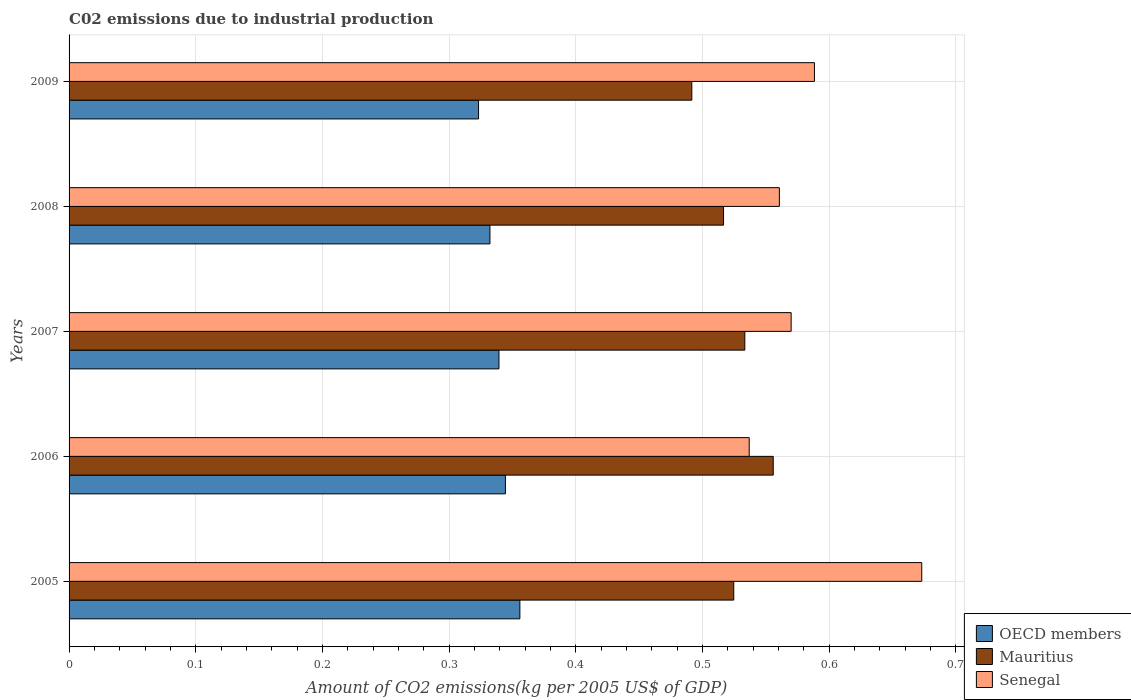How many different coloured bars are there?
Ensure brevity in your answer.  3. How many bars are there on the 5th tick from the top?
Keep it short and to the point. 3. What is the label of the 4th group of bars from the top?
Your answer should be very brief. 2006. What is the amount of CO2 emitted due to industrial production in Mauritius in 2008?
Your answer should be very brief. 0.52. Across all years, what is the maximum amount of CO2 emitted due to industrial production in Senegal?
Provide a short and direct response. 0.67. Across all years, what is the minimum amount of CO2 emitted due to industrial production in Mauritius?
Offer a very short reply. 0.49. In which year was the amount of CO2 emitted due to industrial production in Senegal minimum?
Offer a terse response. 2006. What is the total amount of CO2 emitted due to industrial production in Mauritius in the graph?
Your response must be concise. 2.62. What is the difference between the amount of CO2 emitted due to industrial production in Senegal in 2006 and that in 2007?
Your answer should be compact. -0.03. What is the difference between the amount of CO2 emitted due to industrial production in OECD members in 2006 and the amount of CO2 emitted due to industrial production in Senegal in 2007?
Give a very brief answer. -0.23. What is the average amount of CO2 emitted due to industrial production in Senegal per year?
Provide a succinct answer. 0.59. In the year 2005, what is the difference between the amount of CO2 emitted due to industrial production in OECD members and amount of CO2 emitted due to industrial production in Mauritius?
Provide a succinct answer. -0.17. What is the ratio of the amount of CO2 emitted due to industrial production in Mauritius in 2005 to that in 2009?
Offer a very short reply. 1.07. What is the difference between the highest and the second highest amount of CO2 emitted due to industrial production in Mauritius?
Provide a short and direct response. 0.02. What is the difference between the highest and the lowest amount of CO2 emitted due to industrial production in Mauritius?
Give a very brief answer. 0.06. What does the 3rd bar from the top in 2007 represents?
Make the answer very short. OECD members. What does the 2nd bar from the bottom in 2008 represents?
Your response must be concise. Mauritius. Is it the case that in every year, the sum of the amount of CO2 emitted due to industrial production in Mauritius and amount of CO2 emitted due to industrial production in Senegal is greater than the amount of CO2 emitted due to industrial production in OECD members?
Give a very brief answer. Yes. How many bars are there?
Provide a succinct answer. 15. Are all the bars in the graph horizontal?
Provide a succinct answer. Yes. What is the difference between two consecutive major ticks on the X-axis?
Your answer should be very brief. 0.1. Does the graph contain grids?
Keep it short and to the point. Yes. How many legend labels are there?
Make the answer very short. 3. How are the legend labels stacked?
Ensure brevity in your answer.  Vertical. What is the title of the graph?
Provide a short and direct response. C02 emissions due to industrial production. Does "Costa Rica" appear as one of the legend labels in the graph?
Make the answer very short. No. What is the label or title of the X-axis?
Your answer should be compact. Amount of CO2 emissions(kg per 2005 US$ of GDP). What is the label or title of the Y-axis?
Keep it short and to the point. Years. What is the Amount of CO2 emissions(kg per 2005 US$ of GDP) of OECD members in 2005?
Give a very brief answer. 0.36. What is the Amount of CO2 emissions(kg per 2005 US$ of GDP) in Mauritius in 2005?
Make the answer very short. 0.52. What is the Amount of CO2 emissions(kg per 2005 US$ of GDP) in Senegal in 2005?
Your answer should be very brief. 0.67. What is the Amount of CO2 emissions(kg per 2005 US$ of GDP) in OECD members in 2006?
Make the answer very short. 0.34. What is the Amount of CO2 emissions(kg per 2005 US$ of GDP) of Mauritius in 2006?
Provide a succinct answer. 0.56. What is the Amount of CO2 emissions(kg per 2005 US$ of GDP) in Senegal in 2006?
Your answer should be very brief. 0.54. What is the Amount of CO2 emissions(kg per 2005 US$ of GDP) in OECD members in 2007?
Keep it short and to the point. 0.34. What is the Amount of CO2 emissions(kg per 2005 US$ of GDP) of Mauritius in 2007?
Your response must be concise. 0.53. What is the Amount of CO2 emissions(kg per 2005 US$ of GDP) of Senegal in 2007?
Your answer should be compact. 0.57. What is the Amount of CO2 emissions(kg per 2005 US$ of GDP) in OECD members in 2008?
Ensure brevity in your answer.  0.33. What is the Amount of CO2 emissions(kg per 2005 US$ of GDP) in Mauritius in 2008?
Keep it short and to the point. 0.52. What is the Amount of CO2 emissions(kg per 2005 US$ of GDP) in Senegal in 2008?
Your answer should be compact. 0.56. What is the Amount of CO2 emissions(kg per 2005 US$ of GDP) in OECD members in 2009?
Ensure brevity in your answer.  0.32. What is the Amount of CO2 emissions(kg per 2005 US$ of GDP) of Mauritius in 2009?
Offer a terse response. 0.49. What is the Amount of CO2 emissions(kg per 2005 US$ of GDP) in Senegal in 2009?
Offer a very short reply. 0.59. Across all years, what is the maximum Amount of CO2 emissions(kg per 2005 US$ of GDP) in OECD members?
Ensure brevity in your answer.  0.36. Across all years, what is the maximum Amount of CO2 emissions(kg per 2005 US$ of GDP) of Mauritius?
Make the answer very short. 0.56. Across all years, what is the maximum Amount of CO2 emissions(kg per 2005 US$ of GDP) of Senegal?
Provide a succinct answer. 0.67. Across all years, what is the minimum Amount of CO2 emissions(kg per 2005 US$ of GDP) of OECD members?
Your answer should be very brief. 0.32. Across all years, what is the minimum Amount of CO2 emissions(kg per 2005 US$ of GDP) in Mauritius?
Ensure brevity in your answer.  0.49. Across all years, what is the minimum Amount of CO2 emissions(kg per 2005 US$ of GDP) of Senegal?
Your answer should be very brief. 0.54. What is the total Amount of CO2 emissions(kg per 2005 US$ of GDP) in OECD members in the graph?
Offer a very short reply. 1.69. What is the total Amount of CO2 emissions(kg per 2005 US$ of GDP) of Mauritius in the graph?
Keep it short and to the point. 2.62. What is the total Amount of CO2 emissions(kg per 2005 US$ of GDP) of Senegal in the graph?
Provide a succinct answer. 2.93. What is the difference between the Amount of CO2 emissions(kg per 2005 US$ of GDP) of OECD members in 2005 and that in 2006?
Your response must be concise. 0.01. What is the difference between the Amount of CO2 emissions(kg per 2005 US$ of GDP) of Mauritius in 2005 and that in 2006?
Your response must be concise. -0.03. What is the difference between the Amount of CO2 emissions(kg per 2005 US$ of GDP) in Senegal in 2005 and that in 2006?
Give a very brief answer. 0.14. What is the difference between the Amount of CO2 emissions(kg per 2005 US$ of GDP) of OECD members in 2005 and that in 2007?
Give a very brief answer. 0.02. What is the difference between the Amount of CO2 emissions(kg per 2005 US$ of GDP) of Mauritius in 2005 and that in 2007?
Give a very brief answer. -0.01. What is the difference between the Amount of CO2 emissions(kg per 2005 US$ of GDP) of Senegal in 2005 and that in 2007?
Your response must be concise. 0.1. What is the difference between the Amount of CO2 emissions(kg per 2005 US$ of GDP) of OECD members in 2005 and that in 2008?
Your answer should be compact. 0.02. What is the difference between the Amount of CO2 emissions(kg per 2005 US$ of GDP) of Mauritius in 2005 and that in 2008?
Offer a very short reply. 0.01. What is the difference between the Amount of CO2 emissions(kg per 2005 US$ of GDP) of Senegal in 2005 and that in 2008?
Offer a very short reply. 0.11. What is the difference between the Amount of CO2 emissions(kg per 2005 US$ of GDP) of OECD members in 2005 and that in 2009?
Your answer should be very brief. 0.03. What is the difference between the Amount of CO2 emissions(kg per 2005 US$ of GDP) of Mauritius in 2005 and that in 2009?
Provide a short and direct response. 0.03. What is the difference between the Amount of CO2 emissions(kg per 2005 US$ of GDP) in Senegal in 2005 and that in 2009?
Ensure brevity in your answer.  0.08. What is the difference between the Amount of CO2 emissions(kg per 2005 US$ of GDP) in OECD members in 2006 and that in 2007?
Offer a very short reply. 0.01. What is the difference between the Amount of CO2 emissions(kg per 2005 US$ of GDP) in Mauritius in 2006 and that in 2007?
Ensure brevity in your answer.  0.02. What is the difference between the Amount of CO2 emissions(kg per 2005 US$ of GDP) in Senegal in 2006 and that in 2007?
Make the answer very short. -0.03. What is the difference between the Amount of CO2 emissions(kg per 2005 US$ of GDP) in OECD members in 2006 and that in 2008?
Give a very brief answer. 0.01. What is the difference between the Amount of CO2 emissions(kg per 2005 US$ of GDP) in Mauritius in 2006 and that in 2008?
Make the answer very short. 0.04. What is the difference between the Amount of CO2 emissions(kg per 2005 US$ of GDP) in Senegal in 2006 and that in 2008?
Offer a terse response. -0.02. What is the difference between the Amount of CO2 emissions(kg per 2005 US$ of GDP) in OECD members in 2006 and that in 2009?
Offer a very short reply. 0.02. What is the difference between the Amount of CO2 emissions(kg per 2005 US$ of GDP) in Mauritius in 2006 and that in 2009?
Your response must be concise. 0.06. What is the difference between the Amount of CO2 emissions(kg per 2005 US$ of GDP) in Senegal in 2006 and that in 2009?
Your response must be concise. -0.05. What is the difference between the Amount of CO2 emissions(kg per 2005 US$ of GDP) in OECD members in 2007 and that in 2008?
Offer a very short reply. 0.01. What is the difference between the Amount of CO2 emissions(kg per 2005 US$ of GDP) of Mauritius in 2007 and that in 2008?
Your answer should be compact. 0.02. What is the difference between the Amount of CO2 emissions(kg per 2005 US$ of GDP) of Senegal in 2007 and that in 2008?
Make the answer very short. 0.01. What is the difference between the Amount of CO2 emissions(kg per 2005 US$ of GDP) of OECD members in 2007 and that in 2009?
Provide a succinct answer. 0.02. What is the difference between the Amount of CO2 emissions(kg per 2005 US$ of GDP) of Mauritius in 2007 and that in 2009?
Offer a terse response. 0.04. What is the difference between the Amount of CO2 emissions(kg per 2005 US$ of GDP) in Senegal in 2007 and that in 2009?
Your answer should be compact. -0.02. What is the difference between the Amount of CO2 emissions(kg per 2005 US$ of GDP) in OECD members in 2008 and that in 2009?
Keep it short and to the point. 0.01. What is the difference between the Amount of CO2 emissions(kg per 2005 US$ of GDP) of Mauritius in 2008 and that in 2009?
Offer a terse response. 0.03. What is the difference between the Amount of CO2 emissions(kg per 2005 US$ of GDP) of Senegal in 2008 and that in 2009?
Your answer should be compact. -0.03. What is the difference between the Amount of CO2 emissions(kg per 2005 US$ of GDP) in OECD members in 2005 and the Amount of CO2 emissions(kg per 2005 US$ of GDP) in Senegal in 2006?
Provide a short and direct response. -0.18. What is the difference between the Amount of CO2 emissions(kg per 2005 US$ of GDP) of Mauritius in 2005 and the Amount of CO2 emissions(kg per 2005 US$ of GDP) of Senegal in 2006?
Offer a very short reply. -0.01. What is the difference between the Amount of CO2 emissions(kg per 2005 US$ of GDP) of OECD members in 2005 and the Amount of CO2 emissions(kg per 2005 US$ of GDP) of Mauritius in 2007?
Your answer should be very brief. -0.18. What is the difference between the Amount of CO2 emissions(kg per 2005 US$ of GDP) in OECD members in 2005 and the Amount of CO2 emissions(kg per 2005 US$ of GDP) in Senegal in 2007?
Your response must be concise. -0.21. What is the difference between the Amount of CO2 emissions(kg per 2005 US$ of GDP) of Mauritius in 2005 and the Amount of CO2 emissions(kg per 2005 US$ of GDP) of Senegal in 2007?
Ensure brevity in your answer.  -0.05. What is the difference between the Amount of CO2 emissions(kg per 2005 US$ of GDP) of OECD members in 2005 and the Amount of CO2 emissions(kg per 2005 US$ of GDP) of Mauritius in 2008?
Offer a terse response. -0.16. What is the difference between the Amount of CO2 emissions(kg per 2005 US$ of GDP) of OECD members in 2005 and the Amount of CO2 emissions(kg per 2005 US$ of GDP) of Senegal in 2008?
Provide a succinct answer. -0.2. What is the difference between the Amount of CO2 emissions(kg per 2005 US$ of GDP) of Mauritius in 2005 and the Amount of CO2 emissions(kg per 2005 US$ of GDP) of Senegal in 2008?
Your answer should be compact. -0.04. What is the difference between the Amount of CO2 emissions(kg per 2005 US$ of GDP) in OECD members in 2005 and the Amount of CO2 emissions(kg per 2005 US$ of GDP) in Mauritius in 2009?
Your response must be concise. -0.14. What is the difference between the Amount of CO2 emissions(kg per 2005 US$ of GDP) of OECD members in 2005 and the Amount of CO2 emissions(kg per 2005 US$ of GDP) of Senegal in 2009?
Keep it short and to the point. -0.23. What is the difference between the Amount of CO2 emissions(kg per 2005 US$ of GDP) of Mauritius in 2005 and the Amount of CO2 emissions(kg per 2005 US$ of GDP) of Senegal in 2009?
Your answer should be very brief. -0.06. What is the difference between the Amount of CO2 emissions(kg per 2005 US$ of GDP) of OECD members in 2006 and the Amount of CO2 emissions(kg per 2005 US$ of GDP) of Mauritius in 2007?
Offer a very short reply. -0.19. What is the difference between the Amount of CO2 emissions(kg per 2005 US$ of GDP) in OECD members in 2006 and the Amount of CO2 emissions(kg per 2005 US$ of GDP) in Senegal in 2007?
Give a very brief answer. -0.23. What is the difference between the Amount of CO2 emissions(kg per 2005 US$ of GDP) in Mauritius in 2006 and the Amount of CO2 emissions(kg per 2005 US$ of GDP) in Senegal in 2007?
Keep it short and to the point. -0.01. What is the difference between the Amount of CO2 emissions(kg per 2005 US$ of GDP) in OECD members in 2006 and the Amount of CO2 emissions(kg per 2005 US$ of GDP) in Mauritius in 2008?
Make the answer very short. -0.17. What is the difference between the Amount of CO2 emissions(kg per 2005 US$ of GDP) of OECD members in 2006 and the Amount of CO2 emissions(kg per 2005 US$ of GDP) of Senegal in 2008?
Give a very brief answer. -0.22. What is the difference between the Amount of CO2 emissions(kg per 2005 US$ of GDP) of Mauritius in 2006 and the Amount of CO2 emissions(kg per 2005 US$ of GDP) of Senegal in 2008?
Provide a succinct answer. -0. What is the difference between the Amount of CO2 emissions(kg per 2005 US$ of GDP) in OECD members in 2006 and the Amount of CO2 emissions(kg per 2005 US$ of GDP) in Mauritius in 2009?
Your answer should be compact. -0.15. What is the difference between the Amount of CO2 emissions(kg per 2005 US$ of GDP) in OECD members in 2006 and the Amount of CO2 emissions(kg per 2005 US$ of GDP) in Senegal in 2009?
Keep it short and to the point. -0.24. What is the difference between the Amount of CO2 emissions(kg per 2005 US$ of GDP) of Mauritius in 2006 and the Amount of CO2 emissions(kg per 2005 US$ of GDP) of Senegal in 2009?
Your response must be concise. -0.03. What is the difference between the Amount of CO2 emissions(kg per 2005 US$ of GDP) in OECD members in 2007 and the Amount of CO2 emissions(kg per 2005 US$ of GDP) in Mauritius in 2008?
Give a very brief answer. -0.18. What is the difference between the Amount of CO2 emissions(kg per 2005 US$ of GDP) of OECD members in 2007 and the Amount of CO2 emissions(kg per 2005 US$ of GDP) of Senegal in 2008?
Provide a short and direct response. -0.22. What is the difference between the Amount of CO2 emissions(kg per 2005 US$ of GDP) in Mauritius in 2007 and the Amount of CO2 emissions(kg per 2005 US$ of GDP) in Senegal in 2008?
Provide a short and direct response. -0.03. What is the difference between the Amount of CO2 emissions(kg per 2005 US$ of GDP) in OECD members in 2007 and the Amount of CO2 emissions(kg per 2005 US$ of GDP) in Mauritius in 2009?
Your answer should be compact. -0.15. What is the difference between the Amount of CO2 emissions(kg per 2005 US$ of GDP) of OECD members in 2007 and the Amount of CO2 emissions(kg per 2005 US$ of GDP) of Senegal in 2009?
Offer a very short reply. -0.25. What is the difference between the Amount of CO2 emissions(kg per 2005 US$ of GDP) in Mauritius in 2007 and the Amount of CO2 emissions(kg per 2005 US$ of GDP) in Senegal in 2009?
Offer a terse response. -0.06. What is the difference between the Amount of CO2 emissions(kg per 2005 US$ of GDP) in OECD members in 2008 and the Amount of CO2 emissions(kg per 2005 US$ of GDP) in Mauritius in 2009?
Keep it short and to the point. -0.16. What is the difference between the Amount of CO2 emissions(kg per 2005 US$ of GDP) of OECD members in 2008 and the Amount of CO2 emissions(kg per 2005 US$ of GDP) of Senegal in 2009?
Offer a terse response. -0.26. What is the difference between the Amount of CO2 emissions(kg per 2005 US$ of GDP) of Mauritius in 2008 and the Amount of CO2 emissions(kg per 2005 US$ of GDP) of Senegal in 2009?
Your answer should be very brief. -0.07. What is the average Amount of CO2 emissions(kg per 2005 US$ of GDP) in OECD members per year?
Your answer should be compact. 0.34. What is the average Amount of CO2 emissions(kg per 2005 US$ of GDP) in Mauritius per year?
Provide a succinct answer. 0.52. What is the average Amount of CO2 emissions(kg per 2005 US$ of GDP) of Senegal per year?
Make the answer very short. 0.59. In the year 2005, what is the difference between the Amount of CO2 emissions(kg per 2005 US$ of GDP) in OECD members and Amount of CO2 emissions(kg per 2005 US$ of GDP) in Mauritius?
Your answer should be very brief. -0.17. In the year 2005, what is the difference between the Amount of CO2 emissions(kg per 2005 US$ of GDP) of OECD members and Amount of CO2 emissions(kg per 2005 US$ of GDP) of Senegal?
Provide a succinct answer. -0.32. In the year 2005, what is the difference between the Amount of CO2 emissions(kg per 2005 US$ of GDP) in Mauritius and Amount of CO2 emissions(kg per 2005 US$ of GDP) in Senegal?
Give a very brief answer. -0.15. In the year 2006, what is the difference between the Amount of CO2 emissions(kg per 2005 US$ of GDP) of OECD members and Amount of CO2 emissions(kg per 2005 US$ of GDP) of Mauritius?
Your answer should be very brief. -0.21. In the year 2006, what is the difference between the Amount of CO2 emissions(kg per 2005 US$ of GDP) of OECD members and Amount of CO2 emissions(kg per 2005 US$ of GDP) of Senegal?
Provide a short and direct response. -0.19. In the year 2006, what is the difference between the Amount of CO2 emissions(kg per 2005 US$ of GDP) in Mauritius and Amount of CO2 emissions(kg per 2005 US$ of GDP) in Senegal?
Provide a short and direct response. 0.02. In the year 2007, what is the difference between the Amount of CO2 emissions(kg per 2005 US$ of GDP) in OECD members and Amount of CO2 emissions(kg per 2005 US$ of GDP) in Mauritius?
Provide a short and direct response. -0.19. In the year 2007, what is the difference between the Amount of CO2 emissions(kg per 2005 US$ of GDP) of OECD members and Amount of CO2 emissions(kg per 2005 US$ of GDP) of Senegal?
Make the answer very short. -0.23. In the year 2007, what is the difference between the Amount of CO2 emissions(kg per 2005 US$ of GDP) of Mauritius and Amount of CO2 emissions(kg per 2005 US$ of GDP) of Senegal?
Provide a succinct answer. -0.04. In the year 2008, what is the difference between the Amount of CO2 emissions(kg per 2005 US$ of GDP) in OECD members and Amount of CO2 emissions(kg per 2005 US$ of GDP) in Mauritius?
Give a very brief answer. -0.18. In the year 2008, what is the difference between the Amount of CO2 emissions(kg per 2005 US$ of GDP) of OECD members and Amount of CO2 emissions(kg per 2005 US$ of GDP) of Senegal?
Give a very brief answer. -0.23. In the year 2008, what is the difference between the Amount of CO2 emissions(kg per 2005 US$ of GDP) of Mauritius and Amount of CO2 emissions(kg per 2005 US$ of GDP) of Senegal?
Keep it short and to the point. -0.04. In the year 2009, what is the difference between the Amount of CO2 emissions(kg per 2005 US$ of GDP) of OECD members and Amount of CO2 emissions(kg per 2005 US$ of GDP) of Mauritius?
Give a very brief answer. -0.17. In the year 2009, what is the difference between the Amount of CO2 emissions(kg per 2005 US$ of GDP) in OECD members and Amount of CO2 emissions(kg per 2005 US$ of GDP) in Senegal?
Make the answer very short. -0.27. In the year 2009, what is the difference between the Amount of CO2 emissions(kg per 2005 US$ of GDP) of Mauritius and Amount of CO2 emissions(kg per 2005 US$ of GDP) of Senegal?
Offer a very short reply. -0.1. What is the ratio of the Amount of CO2 emissions(kg per 2005 US$ of GDP) of OECD members in 2005 to that in 2006?
Offer a terse response. 1.03. What is the ratio of the Amount of CO2 emissions(kg per 2005 US$ of GDP) of Mauritius in 2005 to that in 2006?
Your response must be concise. 0.94. What is the ratio of the Amount of CO2 emissions(kg per 2005 US$ of GDP) in Senegal in 2005 to that in 2006?
Your answer should be very brief. 1.25. What is the ratio of the Amount of CO2 emissions(kg per 2005 US$ of GDP) in OECD members in 2005 to that in 2007?
Your answer should be very brief. 1.05. What is the ratio of the Amount of CO2 emissions(kg per 2005 US$ of GDP) of Mauritius in 2005 to that in 2007?
Make the answer very short. 0.98. What is the ratio of the Amount of CO2 emissions(kg per 2005 US$ of GDP) in Senegal in 2005 to that in 2007?
Keep it short and to the point. 1.18. What is the ratio of the Amount of CO2 emissions(kg per 2005 US$ of GDP) of OECD members in 2005 to that in 2008?
Your response must be concise. 1.07. What is the ratio of the Amount of CO2 emissions(kg per 2005 US$ of GDP) of Mauritius in 2005 to that in 2008?
Your answer should be compact. 1.02. What is the ratio of the Amount of CO2 emissions(kg per 2005 US$ of GDP) of Senegal in 2005 to that in 2008?
Ensure brevity in your answer.  1.2. What is the ratio of the Amount of CO2 emissions(kg per 2005 US$ of GDP) in OECD members in 2005 to that in 2009?
Make the answer very short. 1.1. What is the ratio of the Amount of CO2 emissions(kg per 2005 US$ of GDP) in Mauritius in 2005 to that in 2009?
Provide a short and direct response. 1.07. What is the ratio of the Amount of CO2 emissions(kg per 2005 US$ of GDP) in Senegal in 2005 to that in 2009?
Ensure brevity in your answer.  1.14. What is the ratio of the Amount of CO2 emissions(kg per 2005 US$ of GDP) in Mauritius in 2006 to that in 2007?
Offer a terse response. 1.04. What is the ratio of the Amount of CO2 emissions(kg per 2005 US$ of GDP) of Senegal in 2006 to that in 2007?
Make the answer very short. 0.94. What is the ratio of the Amount of CO2 emissions(kg per 2005 US$ of GDP) in OECD members in 2006 to that in 2008?
Your response must be concise. 1.04. What is the ratio of the Amount of CO2 emissions(kg per 2005 US$ of GDP) of Mauritius in 2006 to that in 2008?
Provide a succinct answer. 1.08. What is the ratio of the Amount of CO2 emissions(kg per 2005 US$ of GDP) of Senegal in 2006 to that in 2008?
Your response must be concise. 0.96. What is the ratio of the Amount of CO2 emissions(kg per 2005 US$ of GDP) in OECD members in 2006 to that in 2009?
Offer a very short reply. 1.07. What is the ratio of the Amount of CO2 emissions(kg per 2005 US$ of GDP) of Mauritius in 2006 to that in 2009?
Offer a terse response. 1.13. What is the ratio of the Amount of CO2 emissions(kg per 2005 US$ of GDP) of Senegal in 2006 to that in 2009?
Offer a very short reply. 0.91. What is the ratio of the Amount of CO2 emissions(kg per 2005 US$ of GDP) of OECD members in 2007 to that in 2008?
Offer a terse response. 1.02. What is the ratio of the Amount of CO2 emissions(kg per 2005 US$ of GDP) in Mauritius in 2007 to that in 2008?
Provide a short and direct response. 1.03. What is the ratio of the Amount of CO2 emissions(kg per 2005 US$ of GDP) of Senegal in 2007 to that in 2008?
Make the answer very short. 1.02. What is the ratio of the Amount of CO2 emissions(kg per 2005 US$ of GDP) of OECD members in 2007 to that in 2009?
Provide a succinct answer. 1.05. What is the ratio of the Amount of CO2 emissions(kg per 2005 US$ of GDP) of Mauritius in 2007 to that in 2009?
Offer a terse response. 1.09. What is the ratio of the Amount of CO2 emissions(kg per 2005 US$ of GDP) in Senegal in 2007 to that in 2009?
Provide a succinct answer. 0.97. What is the ratio of the Amount of CO2 emissions(kg per 2005 US$ of GDP) in OECD members in 2008 to that in 2009?
Offer a very short reply. 1.03. What is the ratio of the Amount of CO2 emissions(kg per 2005 US$ of GDP) of Mauritius in 2008 to that in 2009?
Your answer should be compact. 1.05. What is the ratio of the Amount of CO2 emissions(kg per 2005 US$ of GDP) in Senegal in 2008 to that in 2009?
Provide a succinct answer. 0.95. What is the difference between the highest and the second highest Amount of CO2 emissions(kg per 2005 US$ of GDP) of OECD members?
Your answer should be compact. 0.01. What is the difference between the highest and the second highest Amount of CO2 emissions(kg per 2005 US$ of GDP) of Mauritius?
Provide a succinct answer. 0.02. What is the difference between the highest and the second highest Amount of CO2 emissions(kg per 2005 US$ of GDP) in Senegal?
Keep it short and to the point. 0.08. What is the difference between the highest and the lowest Amount of CO2 emissions(kg per 2005 US$ of GDP) in OECD members?
Ensure brevity in your answer.  0.03. What is the difference between the highest and the lowest Amount of CO2 emissions(kg per 2005 US$ of GDP) of Mauritius?
Offer a terse response. 0.06. What is the difference between the highest and the lowest Amount of CO2 emissions(kg per 2005 US$ of GDP) of Senegal?
Offer a very short reply. 0.14. 